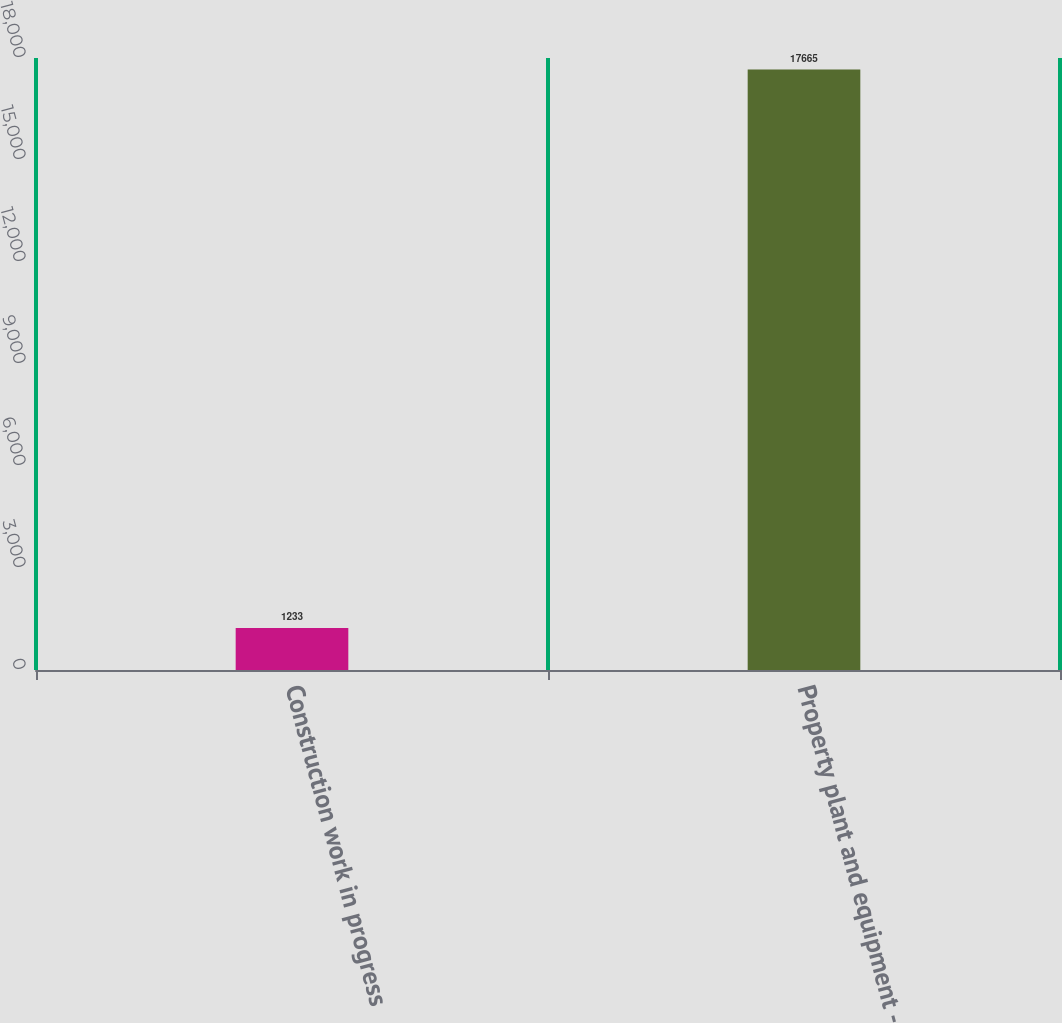<chart> <loc_0><loc_0><loc_500><loc_500><bar_chart><fcel>Construction work in progress<fcel>Property plant and equipment -<nl><fcel>1233<fcel>17665<nl></chart> 